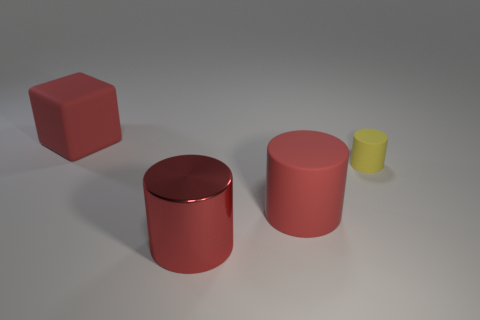Subtract all big metal cylinders. How many cylinders are left? 2 Add 1 red shiny things. How many objects exist? 5 Subtract 1 cylinders. How many cylinders are left? 2 Subtract all red cylinders. How many cylinders are left? 1 Subtract all cylinders. How many objects are left? 1 Subtract all yellow balls. How many brown cubes are left? 0 Subtract 0 green cylinders. How many objects are left? 4 Subtract all gray cylinders. Subtract all red cubes. How many cylinders are left? 3 Subtract all tiny cyan shiny objects. Subtract all big things. How many objects are left? 1 Add 4 shiny objects. How many shiny objects are left? 5 